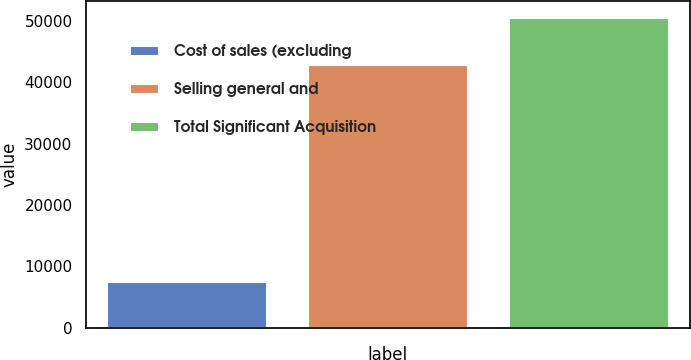<chart> <loc_0><loc_0><loc_500><loc_500><bar_chart><fcel>Cost of sales (excluding<fcel>Selling general and<fcel>Total Significant Acquisition<nl><fcel>7628<fcel>43037<fcel>50665<nl></chart> 